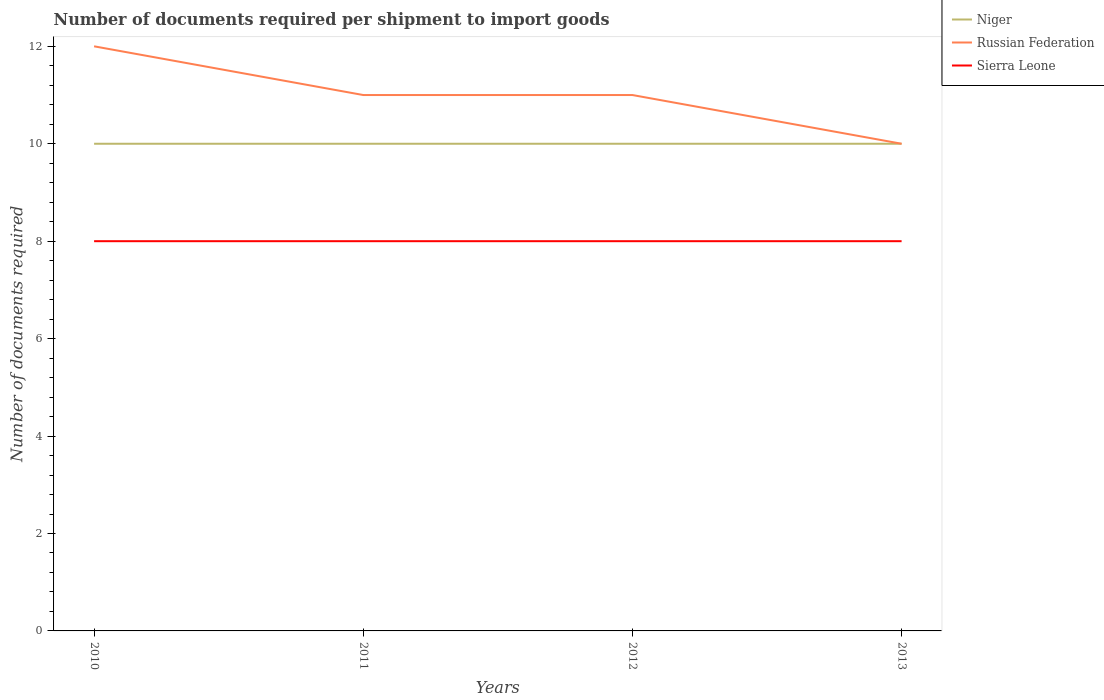How many different coloured lines are there?
Ensure brevity in your answer.  3. Does the line corresponding to Niger intersect with the line corresponding to Sierra Leone?
Offer a terse response. No. Across all years, what is the maximum number of documents required per shipment to import goods in Niger?
Provide a succinct answer. 10. What is the total number of documents required per shipment to import goods in Russian Federation in the graph?
Your answer should be very brief. 1. What is the difference between the highest and the second highest number of documents required per shipment to import goods in Russian Federation?
Your answer should be very brief. 2. How many lines are there?
Your response must be concise. 3. What is the difference between two consecutive major ticks on the Y-axis?
Provide a succinct answer. 2. Where does the legend appear in the graph?
Keep it short and to the point. Top right. How many legend labels are there?
Offer a very short reply. 3. What is the title of the graph?
Make the answer very short. Number of documents required per shipment to import goods. Does "Arab World" appear as one of the legend labels in the graph?
Your answer should be very brief. No. What is the label or title of the X-axis?
Make the answer very short. Years. What is the label or title of the Y-axis?
Offer a terse response. Number of documents required. What is the Number of documents required in Niger in 2010?
Offer a terse response. 10. What is the Number of documents required of Russian Federation in 2010?
Offer a terse response. 12. What is the Number of documents required in Russian Federation in 2011?
Ensure brevity in your answer.  11. What is the Number of documents required of Niger in 2013?
Your answer should be very brief. 10. What is the Number of documents required in Sierra Leone in 2013?
Provide a short and direct response. 8. Across all years, what is the maximum Number of documents required of Niger?
Provide a succinct answer. 10. Across all years, what is the maximum Number of documents required in Sierra Leone?
Provide a short and direct response. 8. Across all years, what is the minimum Number of documents required of Niger?
Make the answer very short. 10. What is the total Number of documents required of Niger in the graph?
Offer a very short reply. 40. What is the total Number of documents required of Russian Federation in the graph?
Offer a very short reply. 44. What is the total Number of documents required of Sierra Leone in the graph?
Offer a terse response. 32. What is the difference between the Number of documents required of Niger in 2010 and that in 2011?
Provide a short and direct response. 0. What is the difference between the Number of documents required of Sierra Leone in 2010 and that in 2011?
Ensure brevity in your answer.  0. What is the difference between the Number of documents required in Russian Federation in 2010 and that in 2012?
Provide a succinct answer. 1. What is the difference between the Number of documents required of Sierra Leone in 2010 and that in 2012?
Offer a very short reply. 0. What is the difference between the Number of documents required of Niger in 2010 and that in 2013?
Offer a terse response. 0. What is the difference between the Number of documents required in Sierra Leone in 2010 and that in 2013?
Offer a very short reply. 0. What is the difference between the Number of documents required in Niger in 2011 and that in 2012?
Your response must be concise. 0. What is the difference between the Number of documents required of Russian Federation in 2011 and that in 2012?
Your answer should be compact. 0. What is the difference between the Number of documents required in Russian Federation in 2011 and that in 2013?
Make the answer very short. 1. What is the difference between the Number of documents required of Niger in 2012 and that in 2013?
Keep it short and to the point. 0. What is the difference between the Number of documents required of Sierra Leone in 2012 and that in 2013?
Give a very brief answer. 0. What is the difference between the Number of documents required of Russian Federation in 2010 and the Number of documents required of Sierra Leone in 2011?
Offer a terse response. 4. What is the difference between the Number of documents required of Niger in 2010 and the Number of documents required of Sierra Leone in 2012?
Ensure brevity in your answer.  2. What is the difference between the Number of documents required in Niger in 2010 and the Number of documents required in Russian Federation in 2013?
Make the answer very short. 0. What is the difference between the Number of documents required in Niger in 2010 and the Number of documents required in Sierra Leone in 2013?
Give a very brief answer. 2. What is the difference between the Number of documents required in Niger in 2011 and the Number of documents required in Sierra Leone in 2012?
Your answer should be very brief. 2. What is the difference between the Number of documents required in Russian Federation in 2011 and the Number of documents required in Sierra Leone in 2012?
Your answer should be very brief. 3. What is the difference between the Number of documents required of Niger in 2012 and the Number of documents required of Sierra Leone in 2013?
Give a very brief answer. 2. What is the difference between the Number of documents required in Russian Federation in 2012 and the Number of documents required in Sierra Leone in 2013?
Your answer should be very brief. 3. What is the average Number of documents required in Russian Federation per year?
Offer a terse response. 11. What is the average Number of documents required in Sierra Leone per year?
Your response must be concise. 8. In the year 2010, what is the difference between the Number of documents required in Russian Federation and Number of documents required in Sierra Leone?
Provide a short and direct response. 4. In the year 2011, what is the difference between the Number of documents required in Niger and Number of documents required in Russian Federation?
Offer a terse response. -1. In the year 2012, what is the difference between the Number of documents required in Niger and Number of documents required in Russian Federation?
Provide a short and direct response. -1. In the year 2013, what is the difference between the Number of documents required in Niger and Number of documents required in Sierra Leone?
Make the answer very short. 2. What is the ratio of the Number of documents required of Niger in 2010 to that in 2011?
Provide a succinct answer. 1. What is the ratio of the Number of documents required of Sierra Leone in 2010 to that in 2011?
Your answer should be very brief. 1. What is the ratio of the Number of documents required in Russian Federation in 2010 to that in 2012?
Your answer should be compact. 1.09. What is the ratio of the Number of documents required in Niger in 2010 to that in 2013?
Give a very brief answer. 1. What is the ratio of the Number of documents required in Sierra Leone in 2010 to that in 2013?
Provide a succinct answer. 1. What is the ratio of the Number of documents required in Niger in 2011 to that in 2012?
Your answer should be very brief. 1. What is the ratio of the Number of documents required of Russian Federation in 2011 to that in 2013?
Offer a very short reply. 1.1. What is the ratio of the Number of documents required of Sierra Leone in 2011 to that in 2013?
Offer a very short reply. 1. What is the ratio of the Number of documents required of Russian Federation in 2012 to that in 2013?
Keep it short and to the point. 1.1. What is the difference between the highest and the second highest Number of documents required of Niger?
Your answer should be compact. 0. What is the difference between the highest and the lowest Number of documents required of Russian Federation?
Ensure brevity in your answer.  2. What is the difference between the highest and the lowest Number of documents required of Sierra Leone?
Give a very brief answer. 0. 